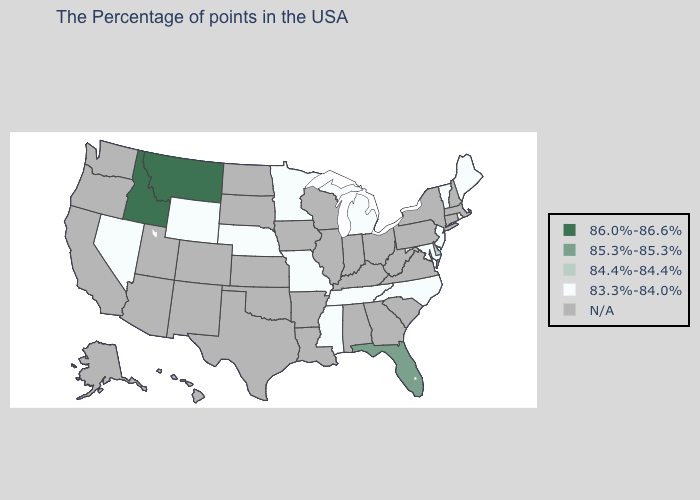What is the value of Wisconsin?
Keep it brief. N/A. What is the highest value in the West ?
Answer briefly. 86.0%-86.6%. What is the value of Missouri?
Quick response, please. 83.3%-84.0%. Does Idaho have the highest value in the USA?
Be succinct. Yes. Does the map have missing data?
Keep it brief. Yes. What is the value of Alaska?
Concise answer only. N/A. What is the value of Idaho?
Write a very short answer. 86.0%-86.6%. What is the value of Louisiana?
Write a very short answer. N/A. What is the value of Florida?
Quick response, please. 85.3%-85.3%. Does North Carolina have the highest value in the South?
Give a very brief answer. No. Does the first symbol in the legend represent the smallest category?
Be succinct. No. What is the value of Georgia?
Concise answer only. N/A. Name the states that have a value in the range 84.4%-84.4%?
Concise answer only. Delaware. 